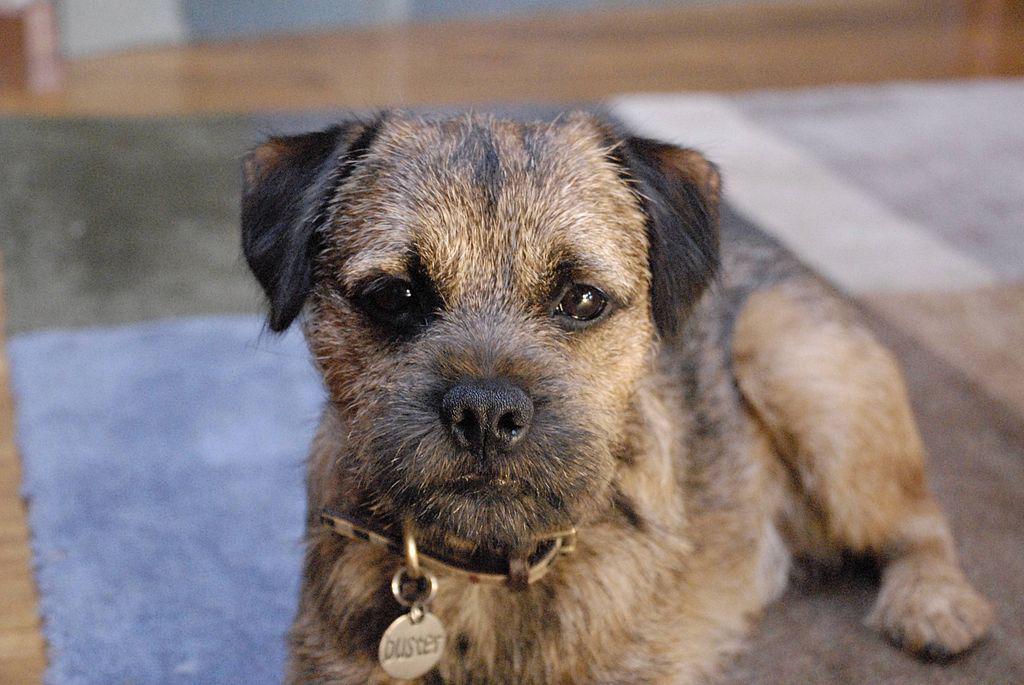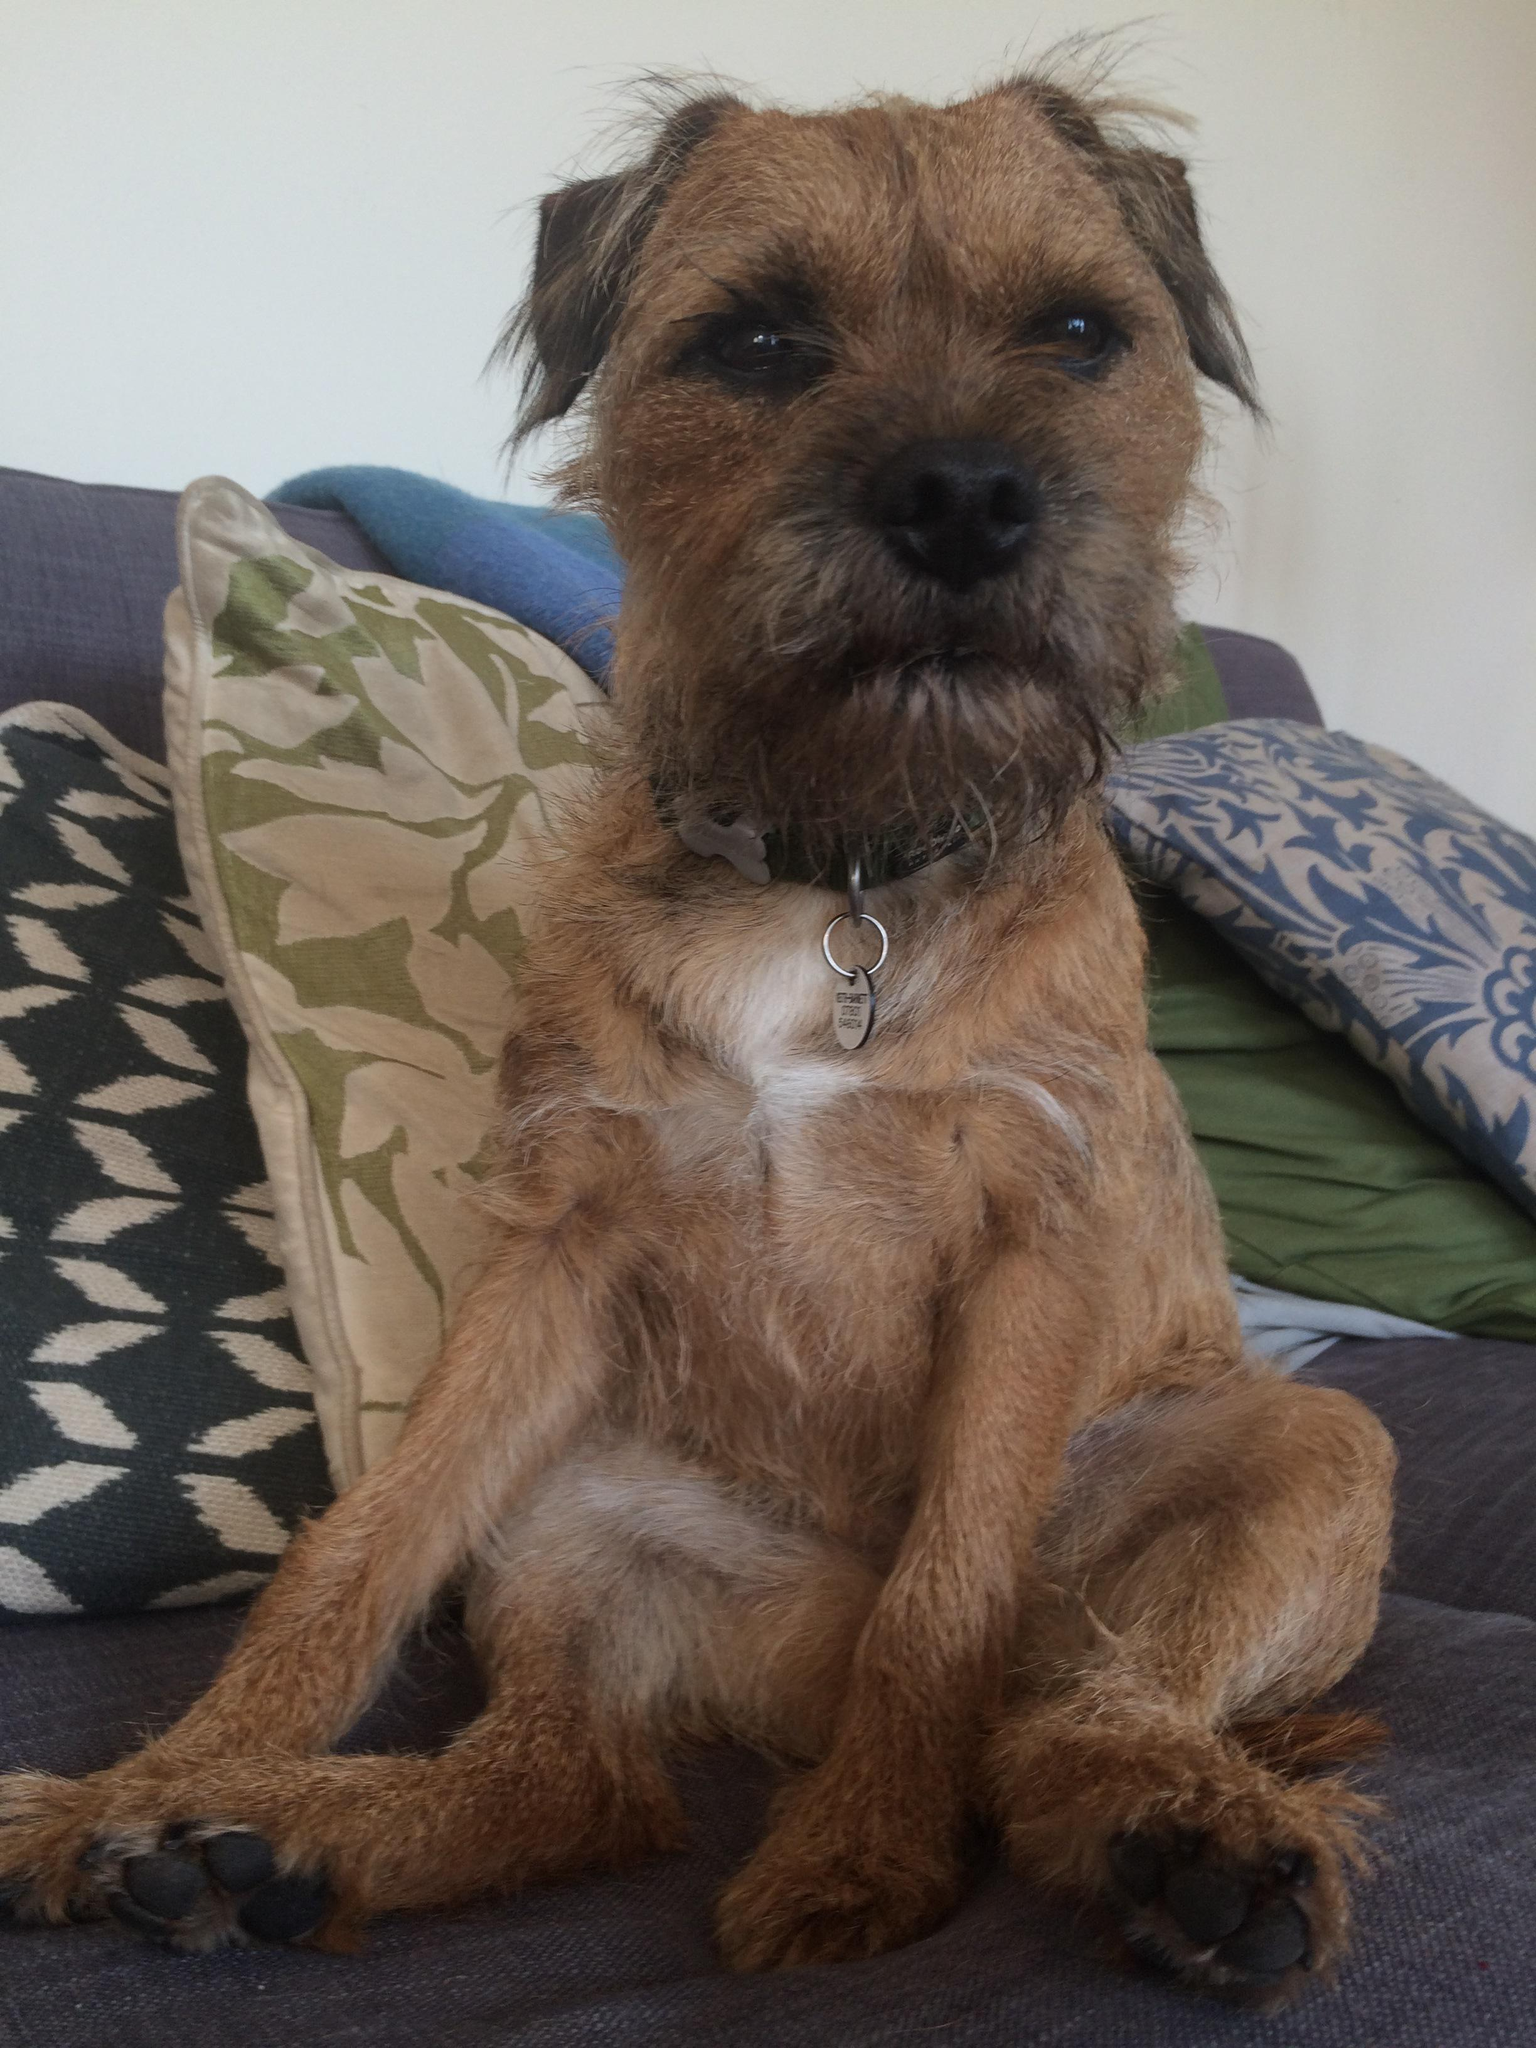The first image is the image on the left, the second image is the image on the right. Analyze the images presented: Is the assertion "The dogs are inside." valid? Answer yes or no. Yes. The first image is the image on the left, the second image is the image on the right. Analyze the images presented: Is the assertion "There are two dogs total outside in the grass." valid? Answer yes or no. No. 